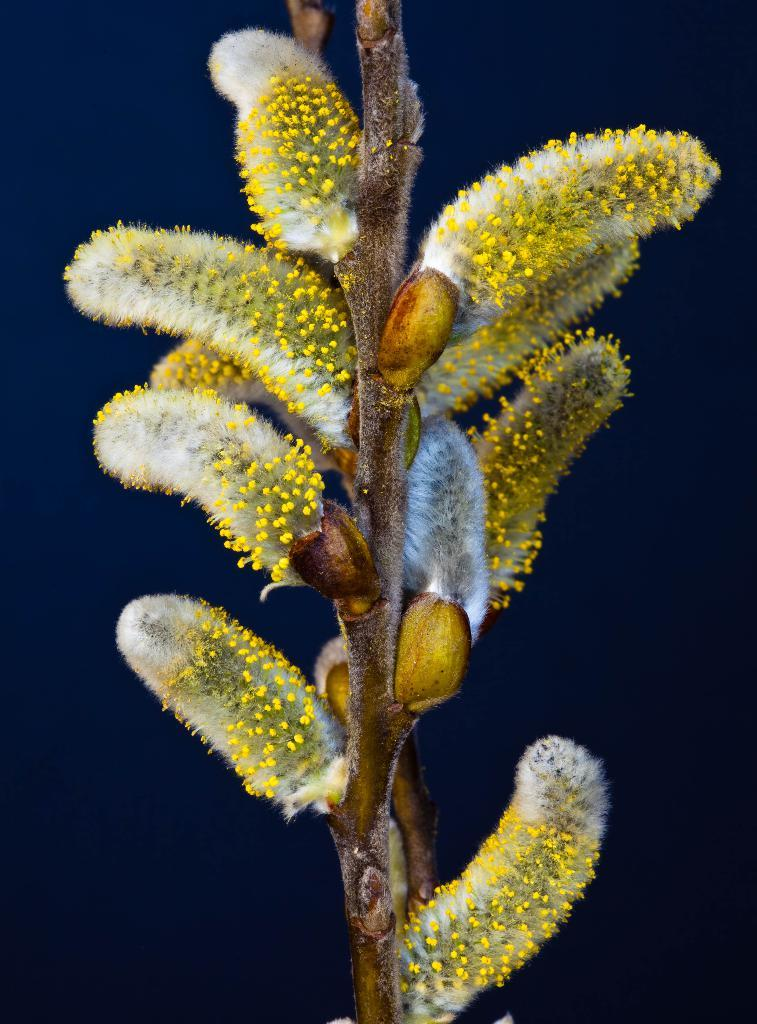What is the main subject of the image? There is a plant in the image. What specific feature of the plant can be observed? The plant has flowers. What colors are the flowers? The flowers are in white and yellow colors. What is the color of the background in the image? The background of the image is dark blue. How many cherries are hanging from the plant in the image? There are no cherries present in the image; it features a plant with white and yellow flowers. What type of skin is visible on the manager in the image? There is no manager or any person present in the image; it only features a plant with flowers. 